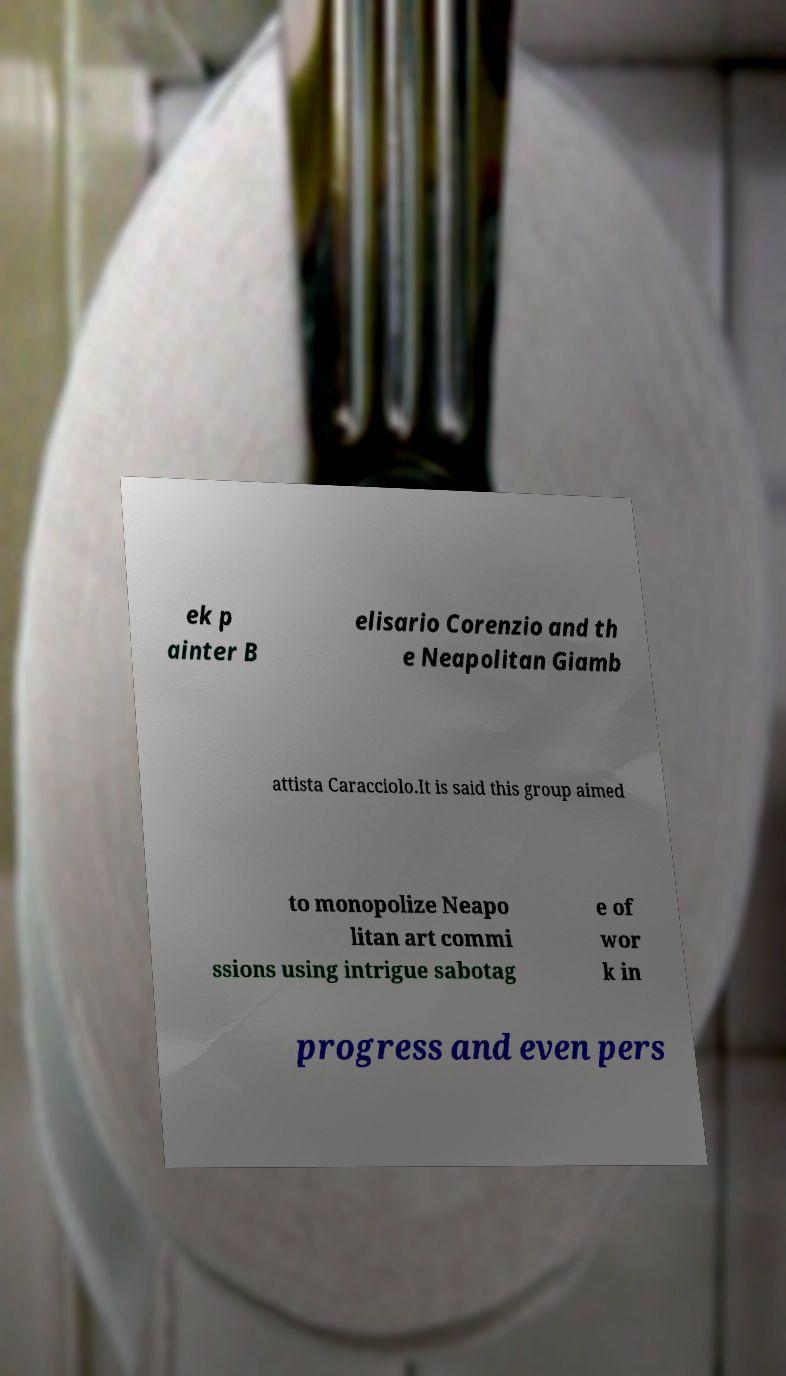Can you read and provide the text displayed in the image?This photo seems to have some interesting text. Can you extract and type it out for me? ek p ainter B elisario Corenzio and th e Neapolitan Giamb attista Caracciolo.It is said this group aimed to monopolize Neapo litan art commi ssions using intrigue sabotag e of wor k in progress and even pers 